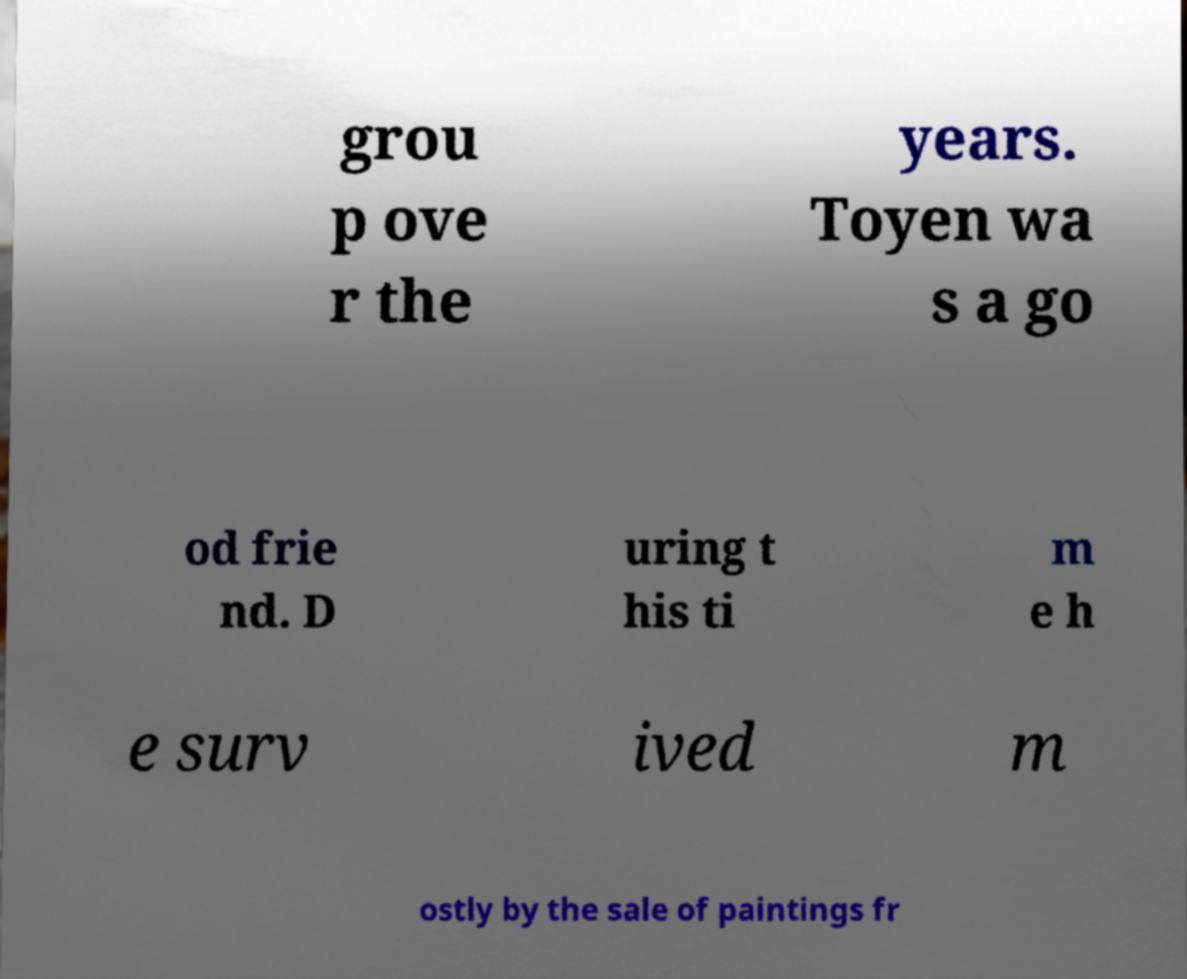I need the written content from this picture converted into text. Can you do that? grou p ove r the years. Toyen wa s a go od frie nd. D uring t his ti m e h e surv ived m ostly by the sale of paintings fr 